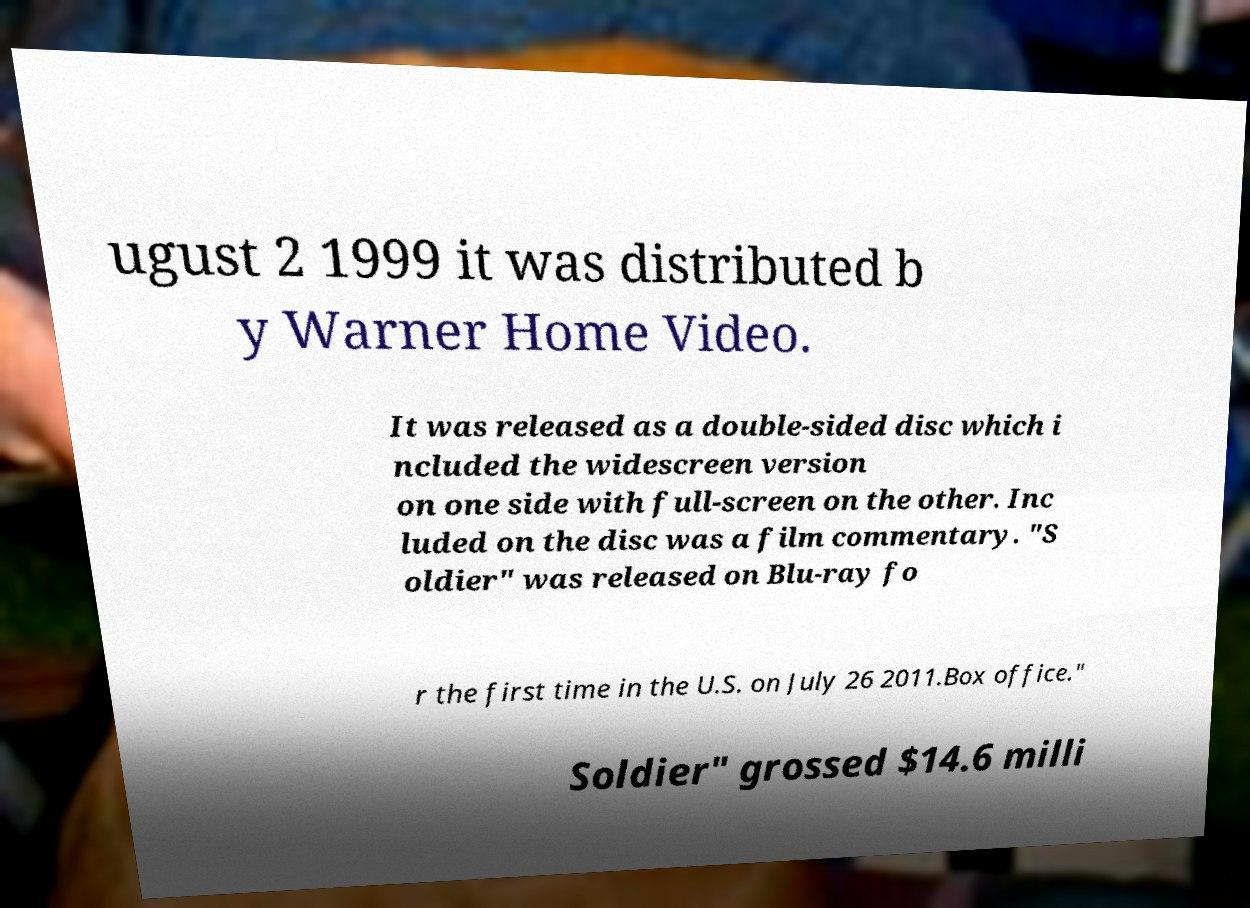Can you read and provide the text displayed in the image?This photo seems to have some interesting text. Can you extract and type it out for me? ugust 2 1999 it was distributed b y Warner Home Video. It was released as a double-sided disc which i ncluded the widescreen version on one side with full-screen on the other. Inc luded on the disc was a film commentary. "S oldier" was released on Blu-ray fo r the first time in the U.S. on July 26 2011.Box office." Soldier" grossed $14.6 milli 